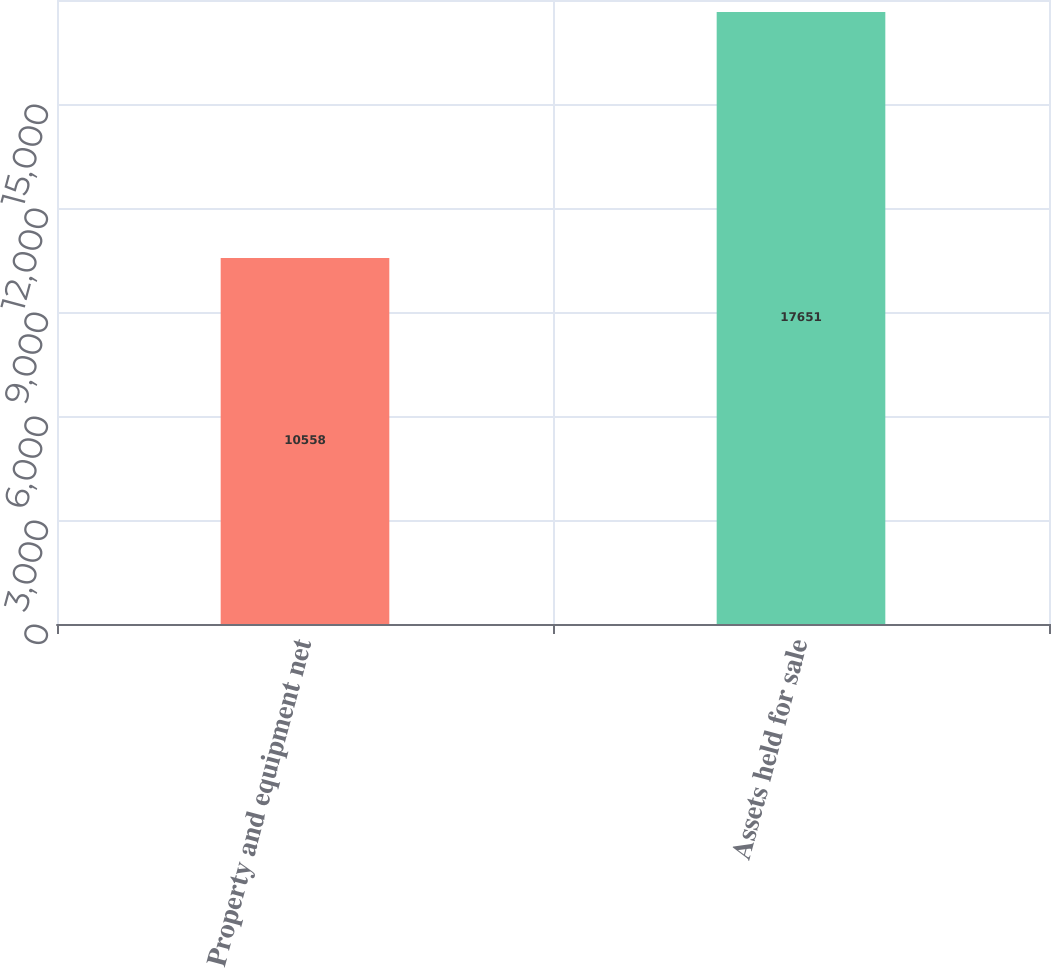Convert chart to OTSL. <chart><loc_0><loc_0><loc_500><loc_500><bar_chart><fcel>Property and equipment net<fcel>Assets held for sale<nl><fcel>10558<fcel>17651<nl></chart> 